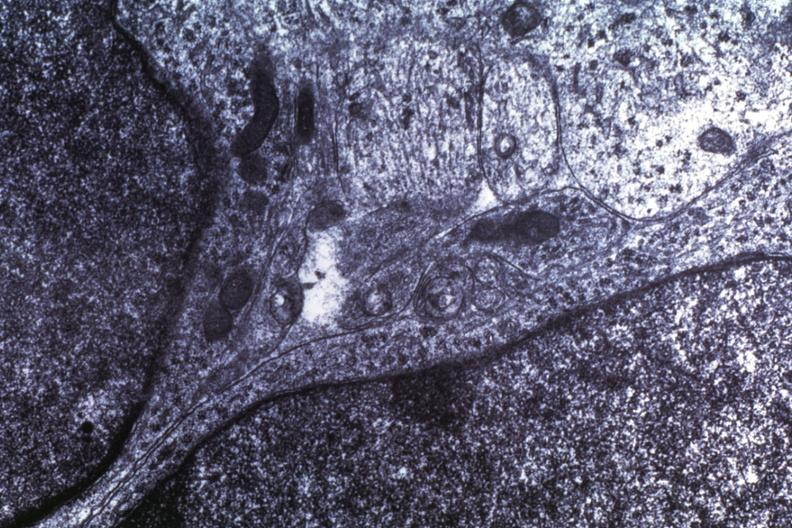s foot present?
Answer the question using a single word or phrase. No 